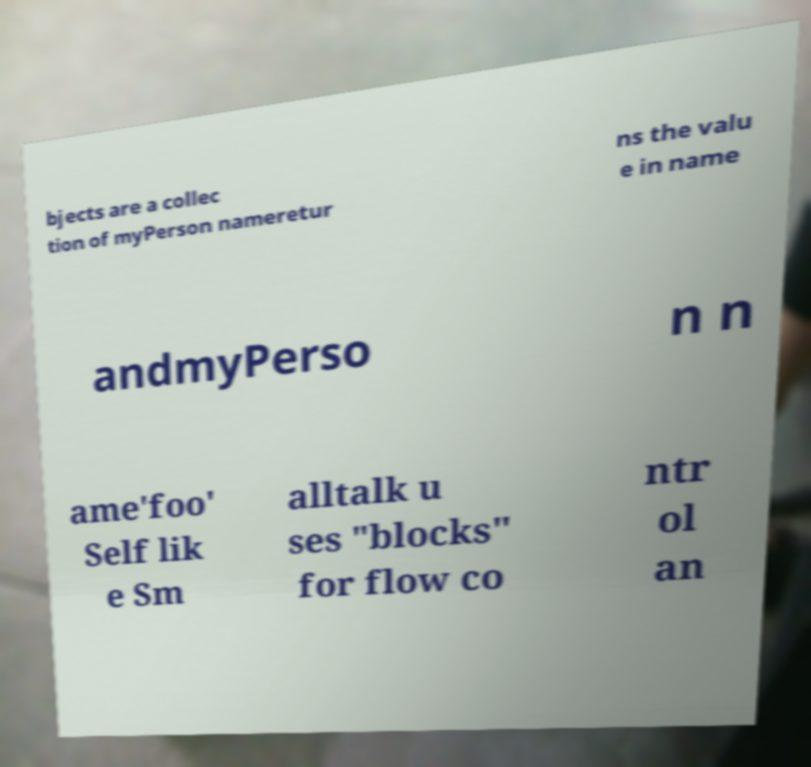Can you read and provide the text displayed in the image?This photo seems to have some interesting text. Can you extract and type it out for me? bjects are a collec tion of myPerson nameretur ns the valu e in name andmyPerso n n ame'foo' Self lik e Sm alltalk u ses "blocks" for flow co ntr ol an 